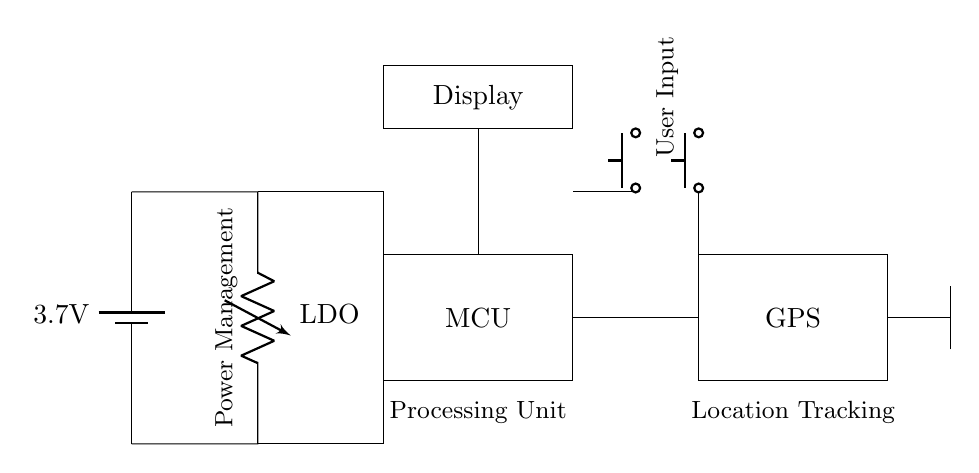What is the input voltage for the circuit? The input voltage is indicated as 3.7 volts, which is specified by the battery symbol in the circuit.
Answer: 3.7 volts What component is responsible for processing? The microcontroller is responsible for processing, as indicated by the labeled rectangle in the circuit diagram.
Answer: Microcontroller How many push buttons are included in the circuit? There are two push buttons represented in the circuit, each drawn as separate components connected to the microcontroller.
Answer: Two What is the function of the voltage regulator in this circuit? The voltage regulator, labeled as LDO, is used to maintain a steady voltage output (3.7 volts) suitable for the circuit components, providing a regulated power supply.
Answer: Regulated power supply How is the GPS module connected to the microcontroller? The GPS module is connected directly to the microcontroller through a trace, indicating a simple connection with no additional components in between to manage the communication.
Answer: Directly connected What is the purpose of the antenna in the circuit? The antenna is used for GPS signal transmission and reception, allowing the wearable device to determine its location based on satellite signals.
Answer: GPS signal reception 